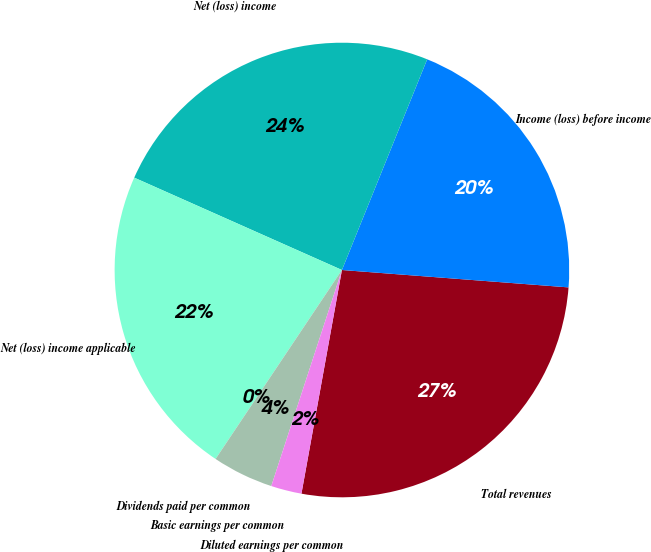Convert chart. <chart><loc_0><loc_0><loc_500><loc_500><pie_chart><fcel>Total revenues<fcel>Income (loss) before income<fcel>Net (loss) income<fcel>Net (loss) income applicable<fcel>Dividends paid per common<fcel>Basic earnings per common<fcel>Diluted earnings per common<nl><fcel>26.63%<fcel>20.1%<fcel>24.46%<fcel>22.28%<fcel>0.0%<fcel>4.35%<fcel>2.18%<nl></chart> 